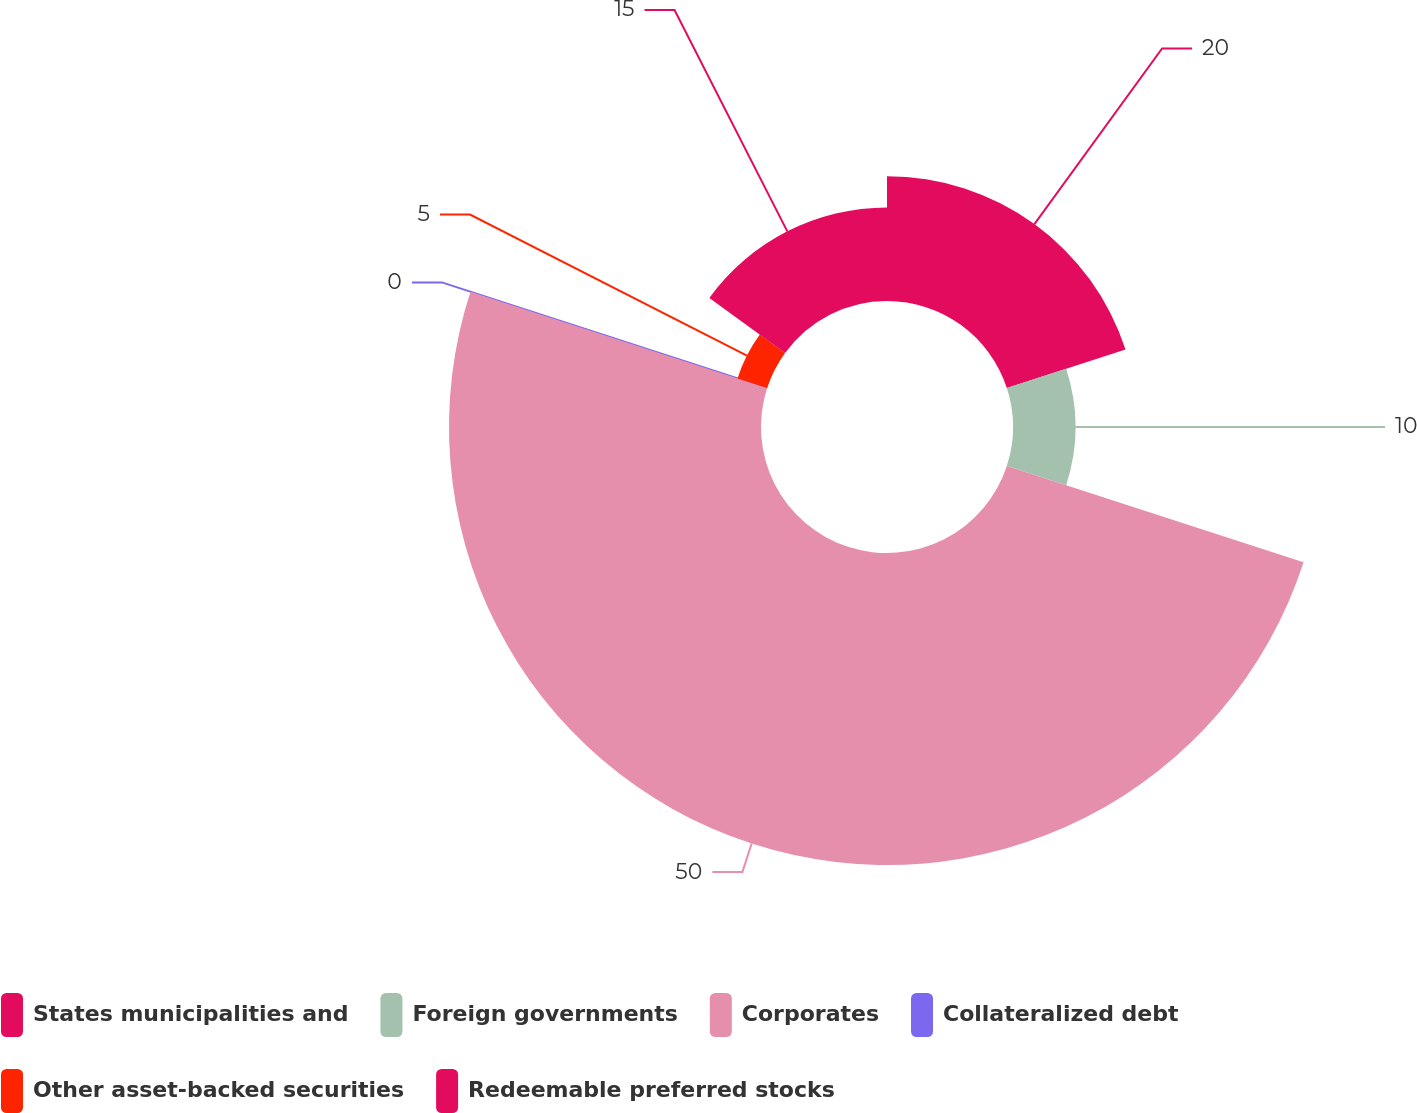<chart> <loc_0><loc_0><loc_500><loc_500><pie_chart><fcel>States municipalities and<fcel>Foreign governments<fcel>Corporates<fcel>Collateralized debt<fcel>Other asset-backed securities<fcel>Redeemable preferred stocks<nl><fcel>20.0%<fcel>10.0%<fcel>50.0%<fcel>0.0%<fcel>5.0%<fcel>15.0%<nl></chart> 